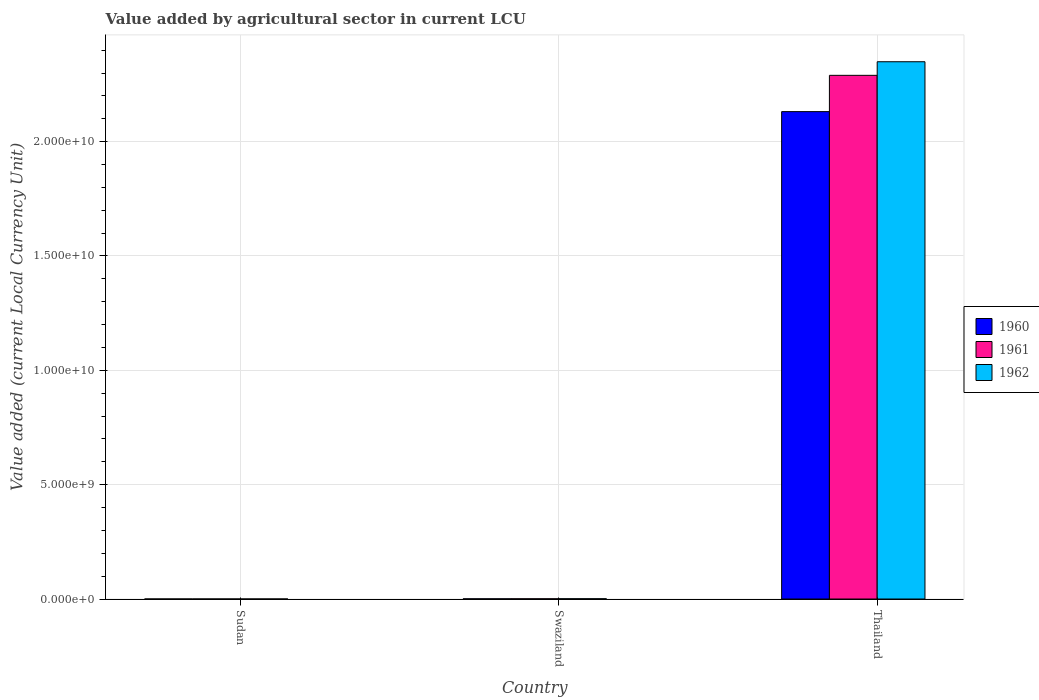How many groups of bars are there?
Provide a succinct answer. 3. How many bars are there on the 2nd tick from the left?
Offer a very short reply. 3. How many bars are there on the 2nd tick from the right?
Your answer should be very brief. 3. What is the label of the 3rd group of bars from the left?
Make the answer very short. Thailand. What is the value added by agricultural sector in 1962 in Swaziland?
Your response must be concise. 1.14e+07. Across all countries, what is the maximum value added by agricultural sector in 1961?
Provide a short and direct response. 2.29e+1. Across all countries, what is the minimum value added by agricultural sector in 1961?
Keep it short and to the point. 2.19e+05. In which country was the value added by agricultural sector in 1961 maximum?
Your answer should be very brief. Thailand. In which country was the value added by agricultural sector in 1960 minimum?
Your answer should be very brief. Sudan. What is the total value added by agricultural sector in 1960 in the graph?
Provide a short and direct response. 2.13e+1. What is the difference between the value added by agricultural sector in 1961 in Sudan and that in Thailand?
Offer a very short reply. -2.29e+1. What is the difference between the value added by agricultural sector in 1962 in Sudan and the value added by agricultural sector in 1960 in Thailand?
Ensure brevity in your answer.  -2.13e+1. What is the average value added by agricultural sector in 1960 per country?
Give a very brief answer. 7.11e+09. What is the difference between the value added by agricultural sector of/in 1960 and value added by agricultural sector of/in 1962 in Thailand?
Offer a very short reply. -2.18e+09. What is the ratio of the value added by agricultural sector in 1962 in Swaziland to that in Thailand?
Provide a short and direct response. 0. Is the value added by agricultural sector in 1960 in Swaziland less than that in Thailand?
Keep it short and to the point. Yes. Is the difference between the value added by agricultural sector in 1960 in Swaziland and Thailand greater than the difference between the value added by agricultural sector in 1962 in Swaziland and Thailand?
Your response must be concise. Yes. What is the difference between the highest and the second highest value added by agricultural sector in 1960?
Offer a very short reply. 7.70e+06. What is the difference between the highest and the lowest value added by agricultural sector in 1960?
Your answer should be very brief. 2.13e+1. Is the sum of the value added by agricultural sector in 1962 in Sudan and Thailand greater than the maximum value added by agricultural sector in 1960 across all countries?
Offer a very short reply. Yes. What does the 2nd bar from the left in Sudan represents?
Offer a terse response. 1961. What does the 3rd bar from the right in Thailand represents?
Keep it short and to the point. 1960. Is it the case that in every country, the sum of the value added by agricultural sector in 1960 and value added by agricultural sector in 1962 is greater than the value added by agricultural sector in 1961?
Offer a very short reply. Yes. How many bars are there?
Your response must be concise. 9. Are the values on the major ticks of Y-axis written in scientific E-notation?
Your answer should be compact. Yes. How many legend labels are there?
Ensure brevity in your answer.  3. How are the legend labels stacked?
Keep it short and to the point. Vertical. What is the title of the graph?
Provide a short and direct response. Value added by agricultural sector in current LCU. Does "1998" appear as one of the legend labels in the graph?
Make the answer very short. No. What is the label or title of the X-axis?
Make the answer very short. Country. What is the label or title of the Y-axis?
Provide a succinct answer. Value added (current Local Currency Unit). What is the Value added (current Local Currency Unit) in 1960 in Sudan?
Give a very brief answer. 2.02e+05. What is the Value added (current Local Currency Unit) in 1961 in Sudan?
Your response must be concise. 2.19e+05. What is the Value added (current Local Currency Unit) in 1962 in Sudan?
Ensure brevity in your answer.  2.31e+05. What is the Value added (current Local Currency Unit) in 1960 in Swaziland?
Provide a short and direct response. 7.90e+06. What is the Value added (current Local Currency Unit) of 1961 in Swaziland?
Make the answer very short. 9.30e+06. What is the Value added (current Local Currency Unit) in 1962 in Swaziland?
Keep it short and to the point. 1.14e+07. What is the Value added (current Local Currency Unit) of 1960 in Thailand?
Offer a very short reply. 2.13e+1. What is the Value added (current Local Currency Unit) in 1961 in Thailand?
Offer a terse response. 2.29e+1. What is the Value added (current Local Currency Unit) of 1962 in Thailand?
Your response must be concise. 2.35e+1. Across all countries, what is the maximum Value added (current Local Currency Unit) of 1960?
Offer a terse response. 2.13e+1. Across all countries, what is the maximum Value added (current Local Currency Unit) in 1961?
Offer a very short reply. 2.29e+1. Across all countries, what is the maximum Value added (current Local Currency Unit) of 1962?
Offer a terse response. 2.35e+1. Across all countries, what is the minimum Value added (current Local Currency Unit) of 1960?
Your answer should be very brief. 2.02e+05. Across all countries, what is the minimum Value added (current Local Currency Unit) in 1961?
Give a very brief answer. 2.19e+05. Across all countries, what is the minimum Value added (current Local Currency Unit) of 1962?
Offer a terse response. 2.31e+05. What is the total Value added (current Local Currency Unit) of 1960 in the graph?
Offer a terse response. 2.13e+1. What is the total Value added (current Local Currency Unit) in 1961 in the graph?
Offer a very short reply. 2.29e+1. What is the total Value added (current Local Currency Unit) in 1962 in the graph?
Give a very brief answer. 2.35e+1. What is the difference between the Value added (current Local Currency Unit) of 1960 in Sudan and that in Swaziland?
Offer a very short reply. -7.70e+06. What is the difference between the Value added (current Local Currency Unit) in 1961 in Sudan and that in Swaziland?
Provide a short and direct response. -9.08e+06. What is the difference between the Value added (current Local Currency Unit) in 1962 in Sudan and that in Swaziland?
Ensure brevity in your answer.  -1.12e+07. What is the difference between the Value added (current Local Currency Unit) in 1960 in Sudan and that in Thailand?
Your response must be concise. -2.13e+1. What is the difference between the Value added (current Local Currency Unit) in 1961 in Sudan and that in Thailand?
Give a very brief answer. -2.29e+1. What is the difference between the Value added (current Local Currency Unit) in 1962 in Sudan and that in Thailand?
Ensure brevity in your answer.  -2.35e+1. What is the difference between the Value added (current Local Currency Unit) in 1960 in Swaziland and that in Thailand?
Offer a terse response. -2.13e+1. What is the difference between the Value added (current Local Currency Unit) of 1961 in Swaziland and that in Thailand?
Keep it short and to the point. -2.29e+1. What is the difference between the Value added (current Local Currency Unit) of 1962 in Swaziland and that in Thailand?
Give a very brief answer. -2.35e+1. What is the difference between the Value added (current Local Currency Unit) of 1960 in Sudan and the Value added (current Local Currency Unit) of 1961 in Swaziland?
Offer a terse response. -9.10e+06. What is the difference between the Value added (current Local Currency Unit) in 1960 in Sudan and the Value added (current Local Currency Unit) in 1962 in Swaziland?
Provide a succinct answer. -1.12e+07. What is the difference between the Value added (current Local Currency Unit) of 1961 in Sudan and the Value added (current Local Currency Unit) of 1962 in Swaziland?
Keep it short and to the point. -1.12e+07. What is the difference between the Value added (current Local Currency Unit) of 1960 in Sudan and the Value added (current Local Currency Unit) of 1961 in Thailand?
Offer a very short reply. -2.29e+1. What is the difference between the Value added (current Local Currency Unit) in 1960 in Sudan and the Value added (current Local Currency Unit) in 1962 in Thailand?
Ensure brevity in your answer.  -2.35e+1. What is the difference between the Value added (current Local Currency Unit) in 1961 in Sudan and the Value added (current Local Currency Unit) in 1962 in Thailand?
Provide a succinct answer. -2.35e+1. What is the difference between the Value added (current Local Currency Unit) in 1960 in Swaziland and the Value added (current Local Currency Unit) in 1961 in Thailand?
Make the answer very short. -2.29e+1. What is the difference between the Value added (current Local Currency Unit) in 1960 in Swaziland and the Value added (current Local Currency Unit) in 1962 in Thailand?
Give a very brief answer. -2.35e+1. What is the difference between the Value added (current Local Currency Unit) of 1961 in Swaziland and the Value added (current Local Currency Unit) of 1962 in Thailand?
Keep it short and to the point. -2.35e+1. What is the average Value added (current Local Currency Unit) in 1960 per country?
Provide a short and direct response. 7.11e+09. What is the average Value added (current Local Currency Unit) of 1961 per country?
Provide a short and direct response. 7.64e+09. What is the average Value added (current Local Currency Unit) in 1962 per country?
Give a very brief answer. 7.83e+09. What is the difference between the Value added (current Local Currency Unit) of 1960 and Value added (current Local Currency Unit) of 1961 in Sudan?
Provide a short and direct response. -1.76e+04. What is the difference between the Value added (current Local Currency Unit) of 1960 and Value added (current Local Currency Unit) of 1962 in Sudan?
Offer a terse response. -2.90e+04. What is the difference between the Value added (current Local Currency Unit) of 1961 and Value added (current Local Currency Unit) of 1962 in Sudan?
Your answer should be very brief. -1.14e+04. What is the difference between the Value added (current Local Currency Unit) in 1960 and Value added (current Local Currency Unit) in 1961 in Swaziland?
Your response must be concise. -1.40e+06. What is the difference between the Value added (current Local Currency Unit) in 1960 and Value added (current Local Currency Unit) in 1962 in Swaziland?
Provide a short and direct response. -3.50e+06. What is the difference between the Value added (current Local Currency Unit) in 1961 and Value added (current Local Currency Unit) in 1962 in Swaziland?
Your answer should be very brief. -2.10e+06. What is the difference between the Value added (current Local Currency Unit) of 1960 and Value added (current Local Currency Unit) of 1961 in Thailand?
Your response must be concise. -1.59e+09. What is the difference between the Value added (current Local Currency Unit) of 1960 and Value added (current Local Currency Unit) of 1962 in Thailand?
Your answer should be very brief. -2.18e+09. What is the difference between the Value added (current Local Currency Unit) in 1961 and Value added (current Local Currency Unit) in 1962 in Thailand?
Offer a terse response. -5.95e+08. What is the ratio of the Value added (current Local Currency Unit) in 1960 in Sudan to that in Swaziland?
Provide a succinct answer. 0.03. What is the ratio of the Value added (current Local Currency Unit) in 1961 in Sudan to that in Swaziland?
Offer a terse response. 0.02. What is the ratio of the Value added (current Local Currency Unit) of 1962 in Sudan to that in Swaziland?
Offer a terse response. 0.02. What is the ratio of the Value added (current Local Currency Unit) in 1961 in Sudan to that in Thailand?
Give a very brief answer. 0. What is the ratio of the Value added (current Local Currency Unit) in 1960 in Swaziland to that in Thailand?
Your response must be concise. 0. What is the ratio of the Value added (current Local Currency Unit) of 1961 in Swaziland to that in Thailand?
Keep it short and to the point. 0. What is the difference between the highest and the second highest Value added (current Local Currency Unit) of 1960?
Ensure brevity in your answer.  2.13e+1. What is the difference between the highest and the second highest Value added (current Local Currency Unit) in 1961?
Your answer should be very brief. 2.29e+1. What is the difference between the highest and the second highest Value added (current Local Currency Unit) in 1962?
Your answer should be compact. 2.35e+1. What is the difference between the highest and the lowest Value added (current Local Currency Unit) in 1960?
Give a very brief answer. 2.13e+1. What is the difference between the highest and the lowest Value added (current Local Currency Unit) in 1961?
Your response must be concise. 2.29e+1. What is the difference between the highest and the lowest Value added (current Local Currency Unit) of 1962?
Provide a succinct answer. 2.35e+1. 